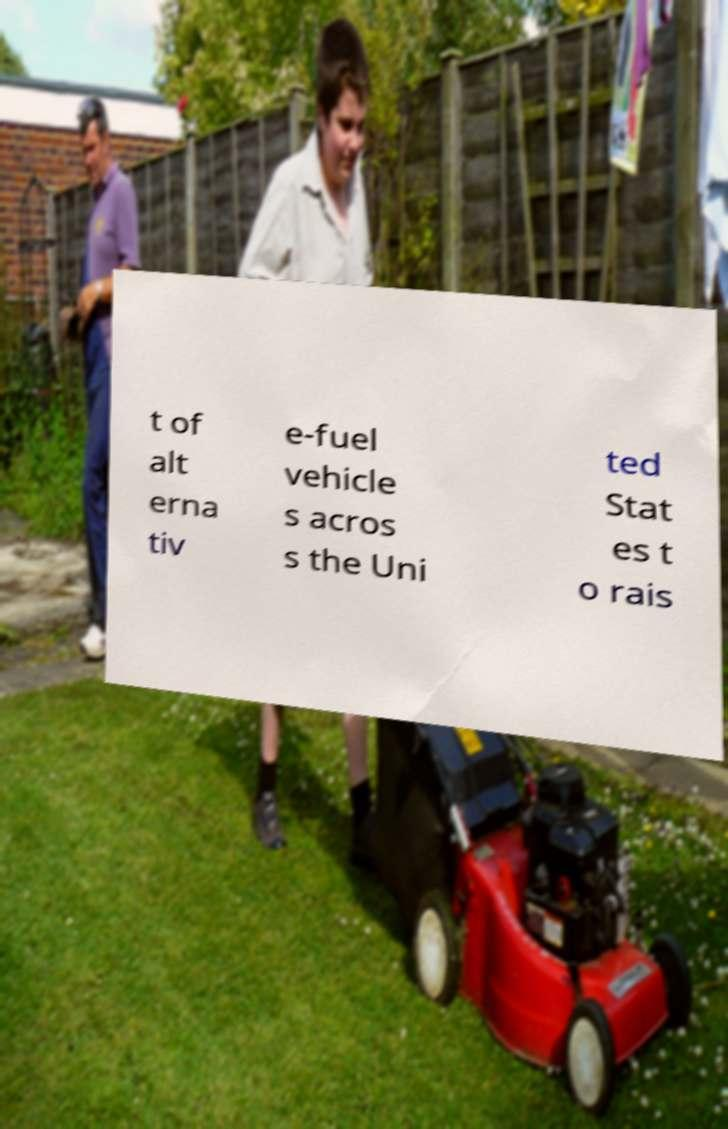Please read and relay the text visible in this image. What does it say? t of alt erna tiv e-fuel vehicle s acros s the Uni ted Stat es t o rais 